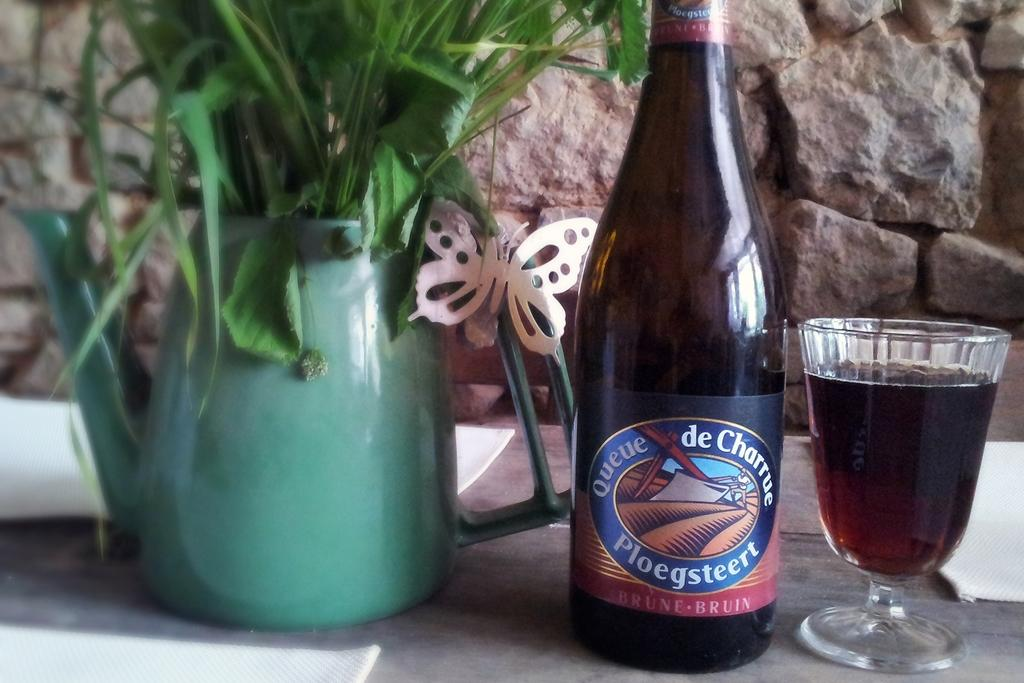<image>
Offer a succinct explanation of the picture presented. a bottle of queue de charrue beside a glass and a flower pot 